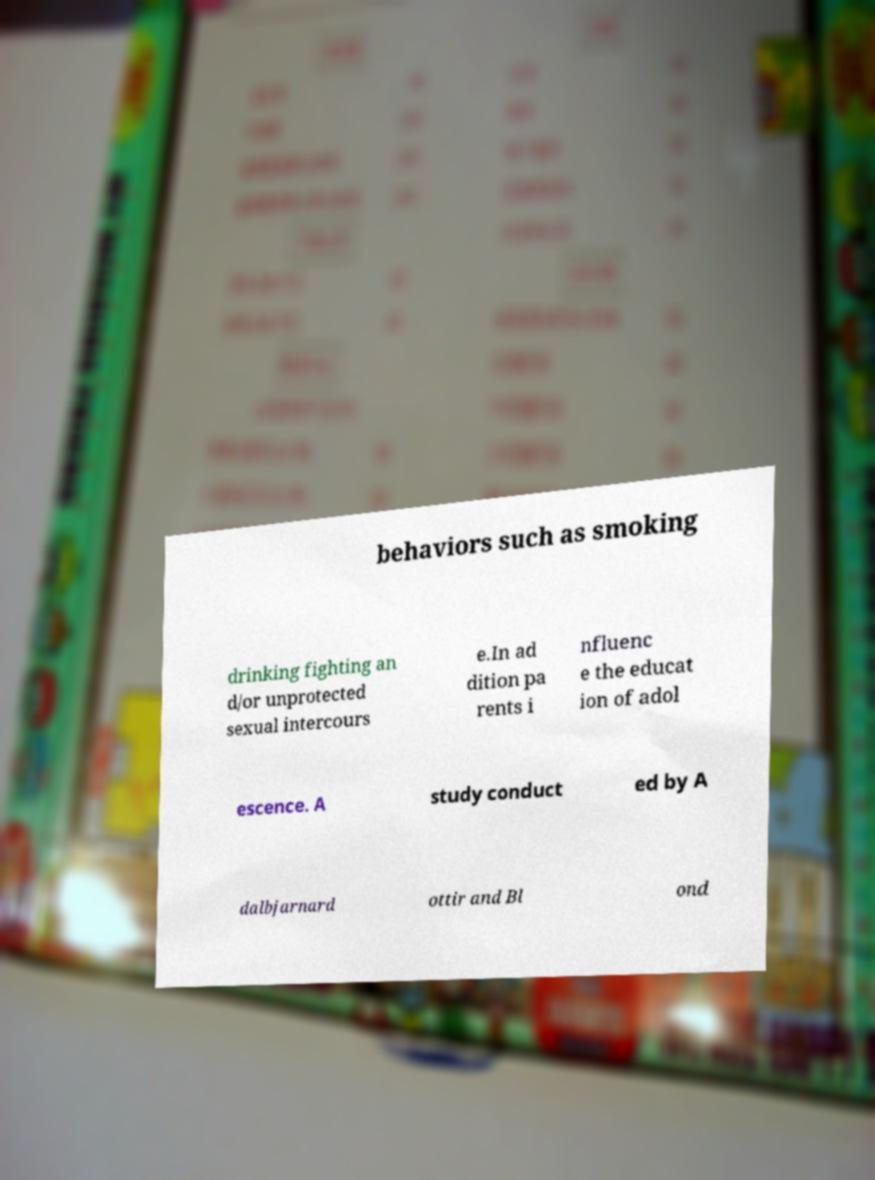Could you extract and type out the text from this image? behaviors such as smoking drinking fighting an d/or unprotected sexual intercours e.In ad dition pa rents i nfluenc e the educat ion of adol escence. A study conduct ed by A dalbjarnard ottir and Bl ond 